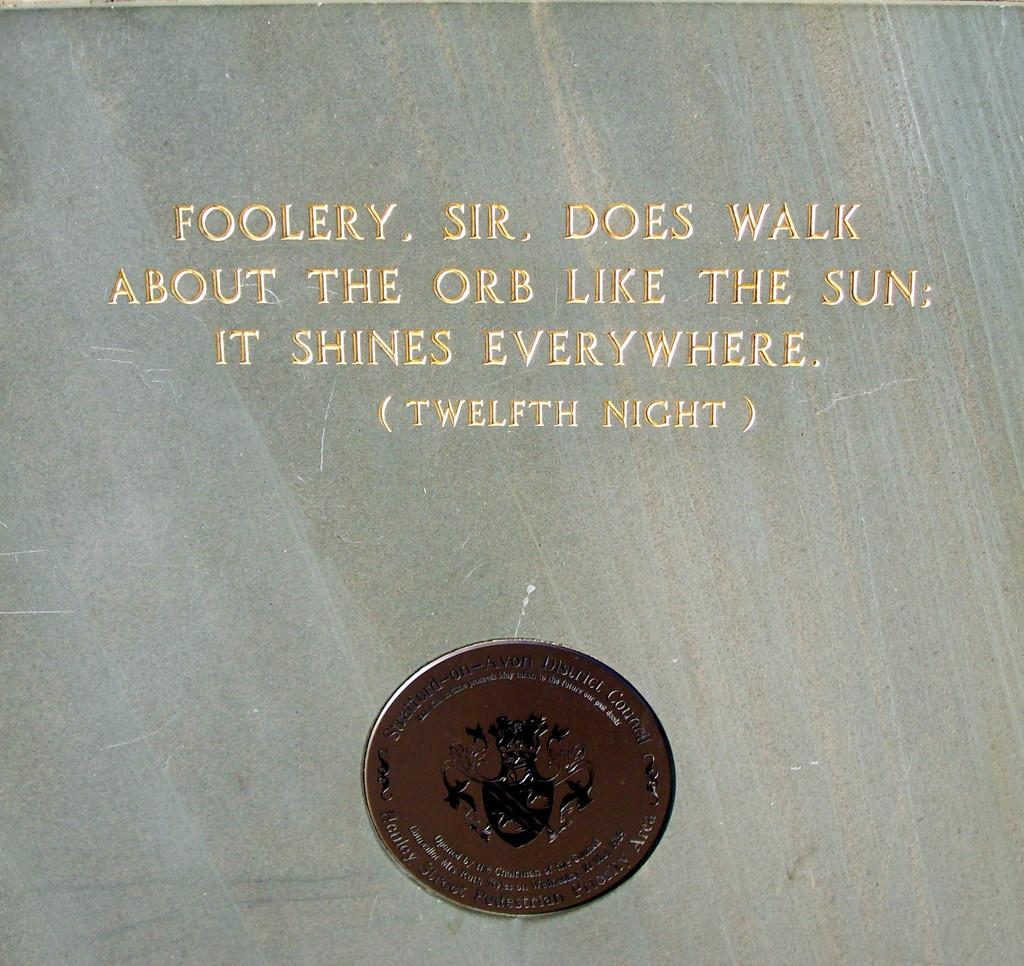<image>
Offer a succinct explanation of the picture presented. A quote from the Twelfth Night inlayed on a marble slab with a Stratford on Avon district council seal. 